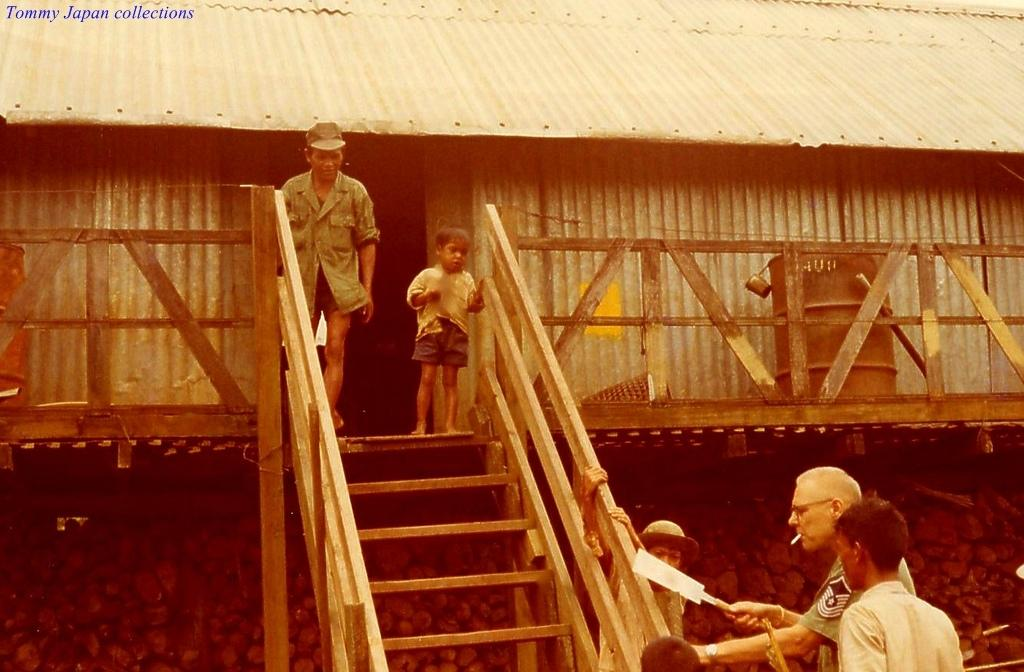What type of structure is present in the image? There is a shed in the image. What can be seen near the shed? There are wooden grills in the image. Are there any architectural features in the image? Yes, there are stairs in the image. What is the purpose of the bin in the image? The bin is likely for waste disposal. Where are the persons standing in the image? Some persons are standing on the ground, while others are standing on the stairs. Can you tell me how many ducks are swimming in the bin in the image? There are no ducks present in the image, and the bin is for waste disposal, not for swimming. What advice would the grandfather give to the persons standing on the stairs in the image? There is no grandfather present in the image, so it is not possible to determine what advice he might give. 